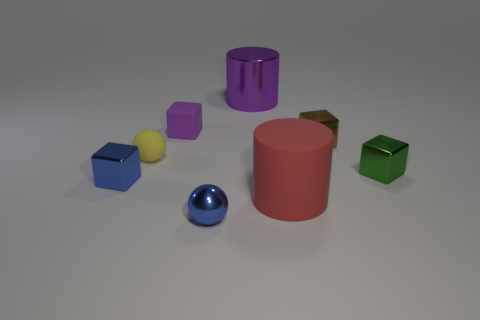There is a yellow ball that is made of the same material as the red thing; what size is it?
Keep it short and to the point. Small. How big is the metal block to the left of the small metal object in front of the small metallic block that is left of the small purple block?
Your answer should be very brief. Small. The matte thing that is in front of the small green cube is what color?
Offer a terse response. Red. Is the number of green shiny things that are to the left of the tiny yellow thing greater than the number of small brown metallic blocks?
Ensure brevity in your answer.  No. There is a blue metallic object in front of the big red cylinder; is its shape the same as the small green object?
Make the answer very short. No. How many red things are big rubber cylinders or rubber spheres?
Your answer should be compact. 1. Are there more large yellow matte spheres than large metallic things?
Provide a short and direct response. No. There is a metallic thing that is the same size as the red rubber object; what color is it?
Keep it short and to the point. Purple. How many cylinders are either small purple matte objects or red matte things?
Give a very brief answer. 1. Is the shape of the large purple object the same as the object that is on the right side of the brown shiny cube?
Keep it short and to the point. No. 